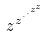<formula> <loc_0><loc_0><loc_500><loc_500>z ^ { z ^ { \cdot ^ { \cdot ^ { z ^ { z } } } } }</formula> 